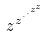<formula> <loc_0><loc_0><loc_500><loc_500>z ^ { z ^ { \cdot ^ { \cdot ^ { z ^ { z } } } } }</formula> 